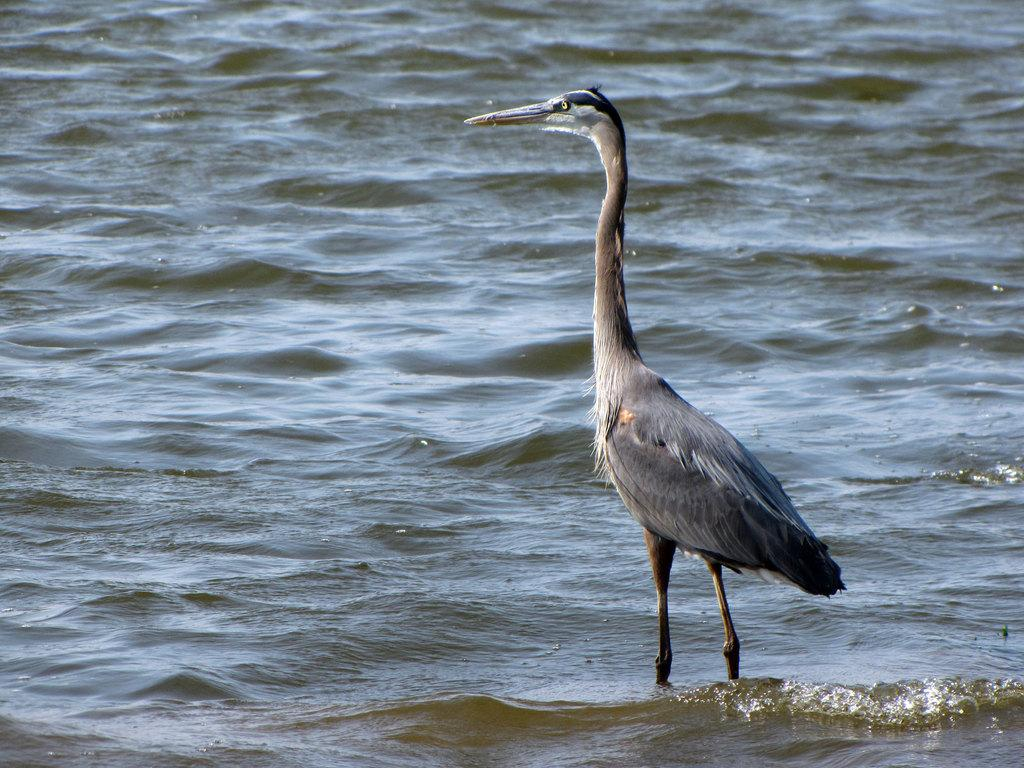What type of animal can be seen in the water in the image? There is a bird in the water in the image. Can you describe the color of the bird? The bird is in gray and white color. Can you see the monkey kicking the flame in the image? There is no monkey or flame present in the image; it features a bird in the water. 